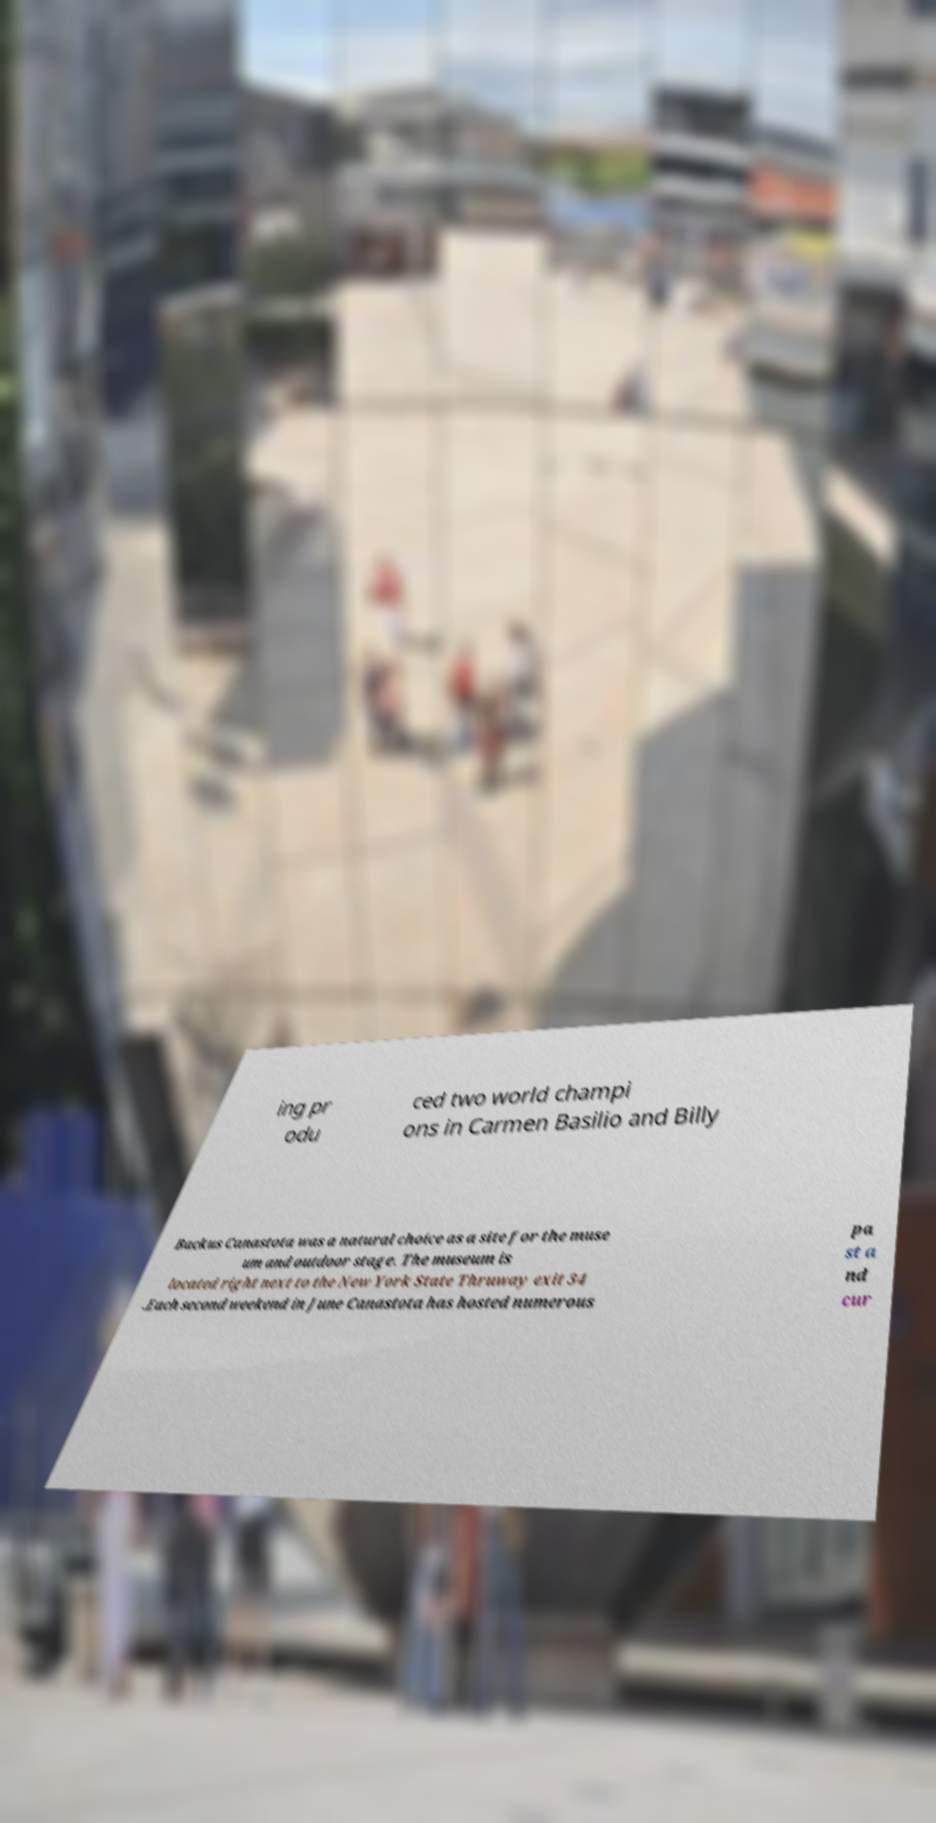Can you read and provide the text displayed in the image?This photo seems to have some interesting text. Can you extract and type it out for me? ing pr odu ced two world champi ons in Carmen Basilio and Billy Backus Canastota was a natural choice as a site for the muse um and outdoor stage. The museum is located right next to the New York State Thruway exit 34 .Each second weekend in June Canastota has hosted numerous pa st a nd cur 